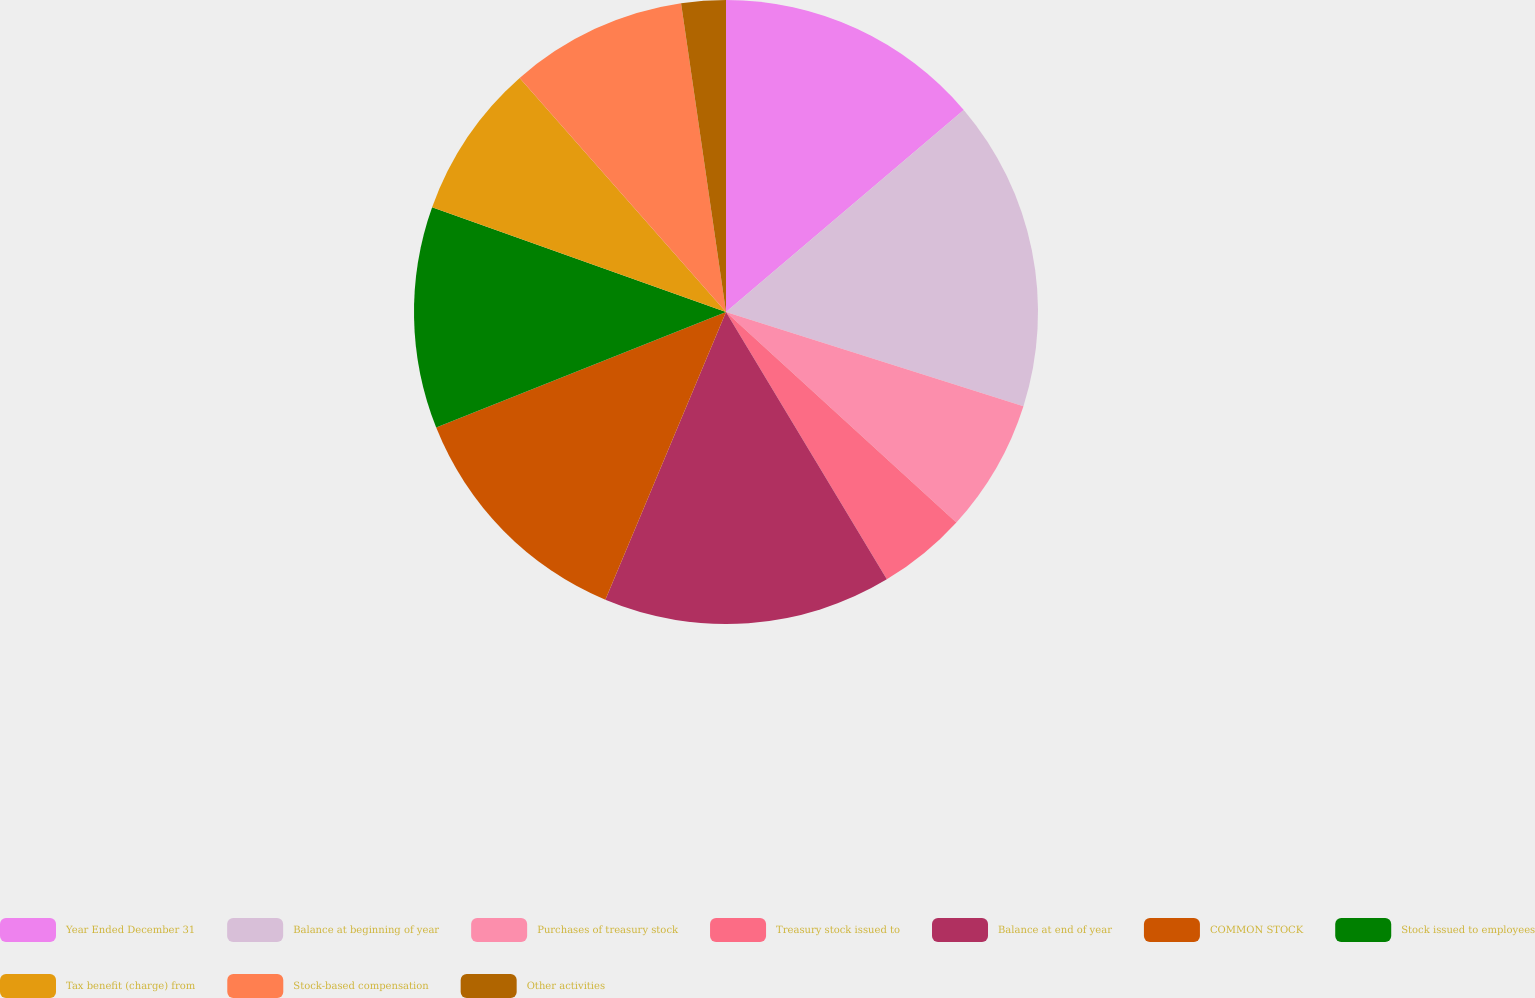<chart> <loc_0><loc_0><loc_500><loc_500><pie_chart><fcel>Year Ended December 31<fcel>Balance at beginning of year<fcel>Purchases of treasury stock<fcel>Treasury stock issued to<fcel>Balance at end of year<fcel>COMMON STOCK<fcel>Stock issued to employees<fcel>Tax benefit (charge) from<fcel>Stock-based compensation<fcel>Other activities<nl><fcel>13.79%<fcel>16.09%<fcel>6.9%<fcel>4.6%<fcel>14.94%<fcel>12.64%<fcel>11.49%<fcel>8.05%<fcel>9.2%<fcel>2.3%<nl></chart> 